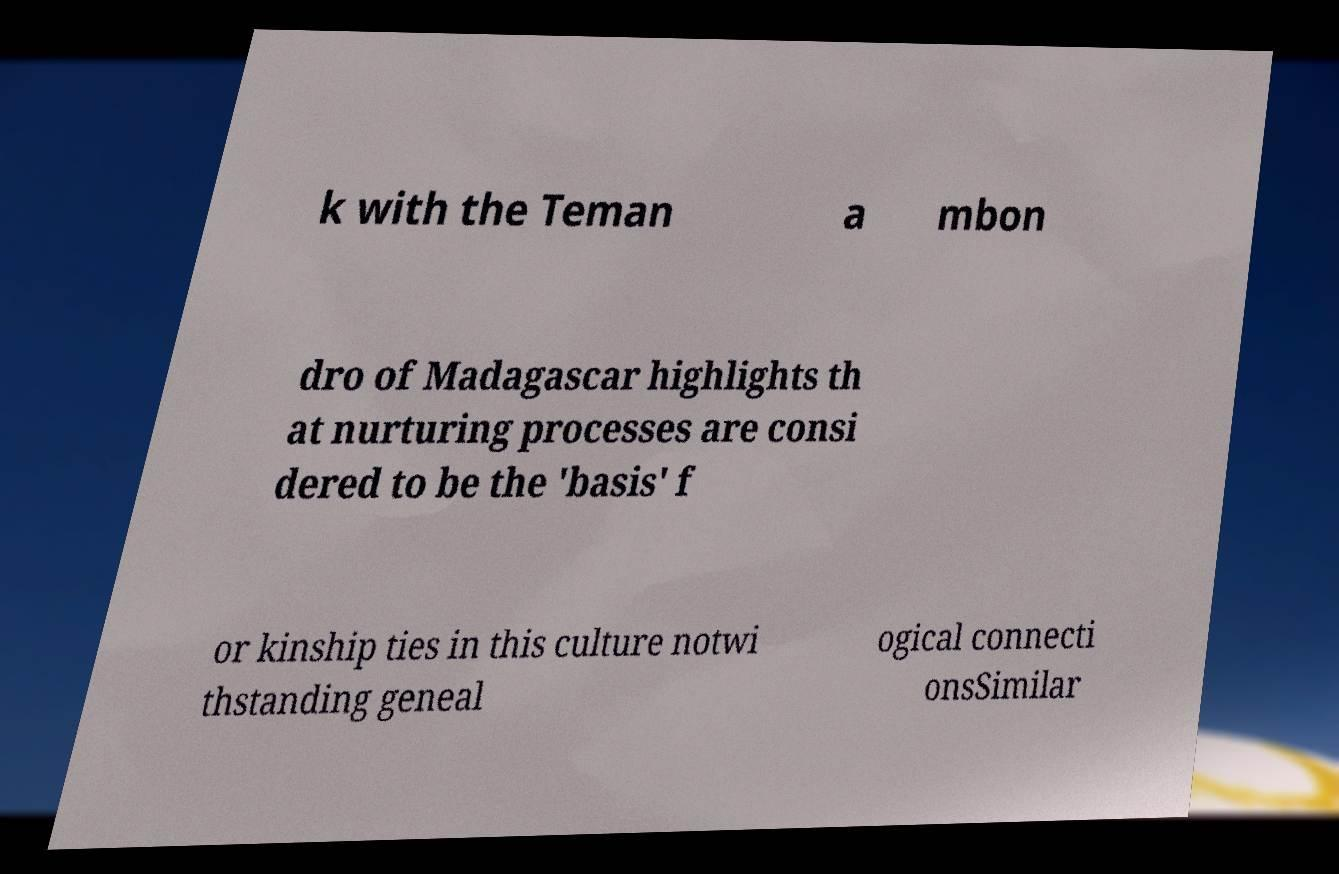Could you extract and type out the text from this image? k with the Teman a mbon dro of Madagascar highlights th at nurturing processes are consi dered to be the 'basis' f or kinship ties in this culture notwi thstanding geneal ogical connecti onsSimilar 